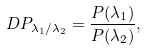<formula> <loc_0><loc_0><loc_500><loc_500>\ D P _ { \lambda _ { 1 } / \lambda _ { 2 } } = \frac { P ( \lambda _ { 1 } ) } { P ( \lambda _ { 2 } ) } ,</formula> 